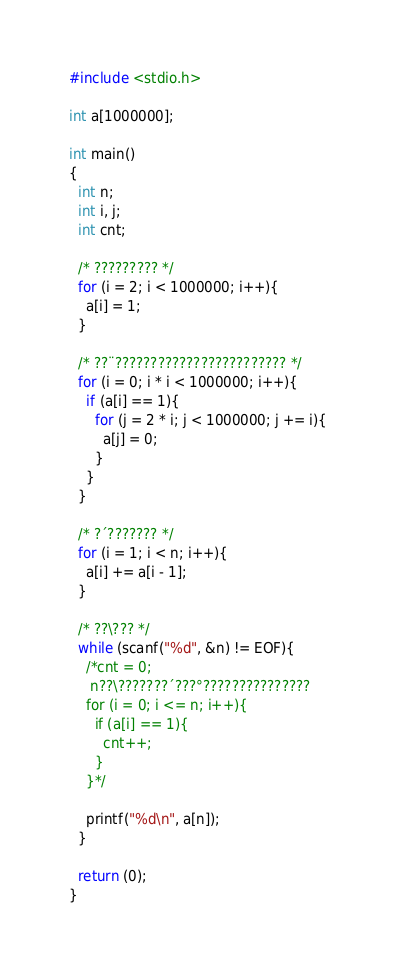Convert code to text. <code><loc_0><loc_0><loc_500><loc_500><_C_>#include <stdio.h>

int a[1000000];

int main()
{
  int n;
  int i, j;
  int cnt;

  /* ????????? */
  for (i = 2; i < 1000000; i++){
    a[i] = 1;
  }

  /* ??¨???????????????????????? */
  for (i = 0; i * i < 1000000; i++){
    if (a[i] == 1){
      for (j = 2 * i; j < 1000000; j += i){
        a[j] = 0;
      }
    }
  }

  /* ?´??????? */
  for (i = 1; i < n; i++){
    a[i] += a[i - 1];
  }

  /* ??\??? */
  while (scanf("%d", &n) != EOF){
    /*cnt = 0;
     n??\???????´???°??????????????? 
    for (i = 0; i <= n; i++){
      if (a[i] == 1){
        cnt++;
      }
    }*/

    printf("%d\n", a[n]);
  }

  return (0);
}</code> 